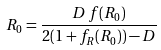<formula> <loc_0><loc_0><loc_500><loc_500>R _ { 0 } = \frac { D \, f ( R _ { 0 } ) } { 2 ( 1 + f _ { R } ( R _ { 0 } ) ) - D }</formula> 